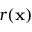<formula> <loc_0><loc_0><loc_500><loc_500>r ( x )</formula> 